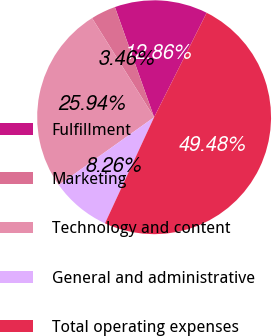Convert chart to OTSL. <chart><loc_0><loc_0><loc_500><loc_500><pie_chart><fcel>Fulfillment<fcel>Marketing<fcel>Technology and content<fcel>General and administrative<fcel>Total operating expenses<nl><fcel>12.86%<fcel>3.46%<fcel>25.94%<fcel>8.26%<fcel>49.48%<nl></chart> 